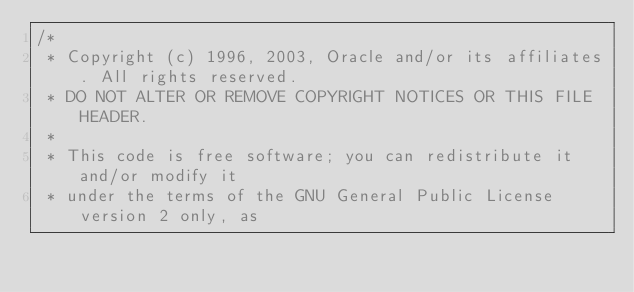<code> <loc_0><loc_0><loc_500><loc_500><_Java_>/*
 * Copyright (c) 1996, 2003, Oracle and/or its affiliates. All rights reserved.
 * DO NOT ALTER OR REMOVE COPYRIGHT NOTICES OR THIS FILE HEADER.
 *
 * This code is free software; you can redistribute it and/or modify it
 * under the terms of the GNU General Public License version 2 only, as</code> 